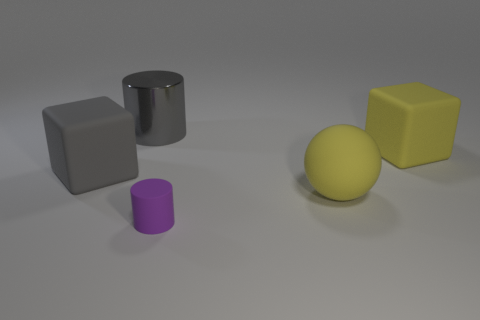Add 3 rubber things. How many objects exist? 8 Subtract all cylinders. How many objects are left? 3 Subtract 0 purple spheres. How many objects are left? 5 Subtract all tiny matte things. Subtract all gray metallic objects. How many objects are left? 3 Add 4 large gray blocks. How many large gray blocks are left? 5 Add 4 yellow matte objects. How many yellow matte objects exist? 6 